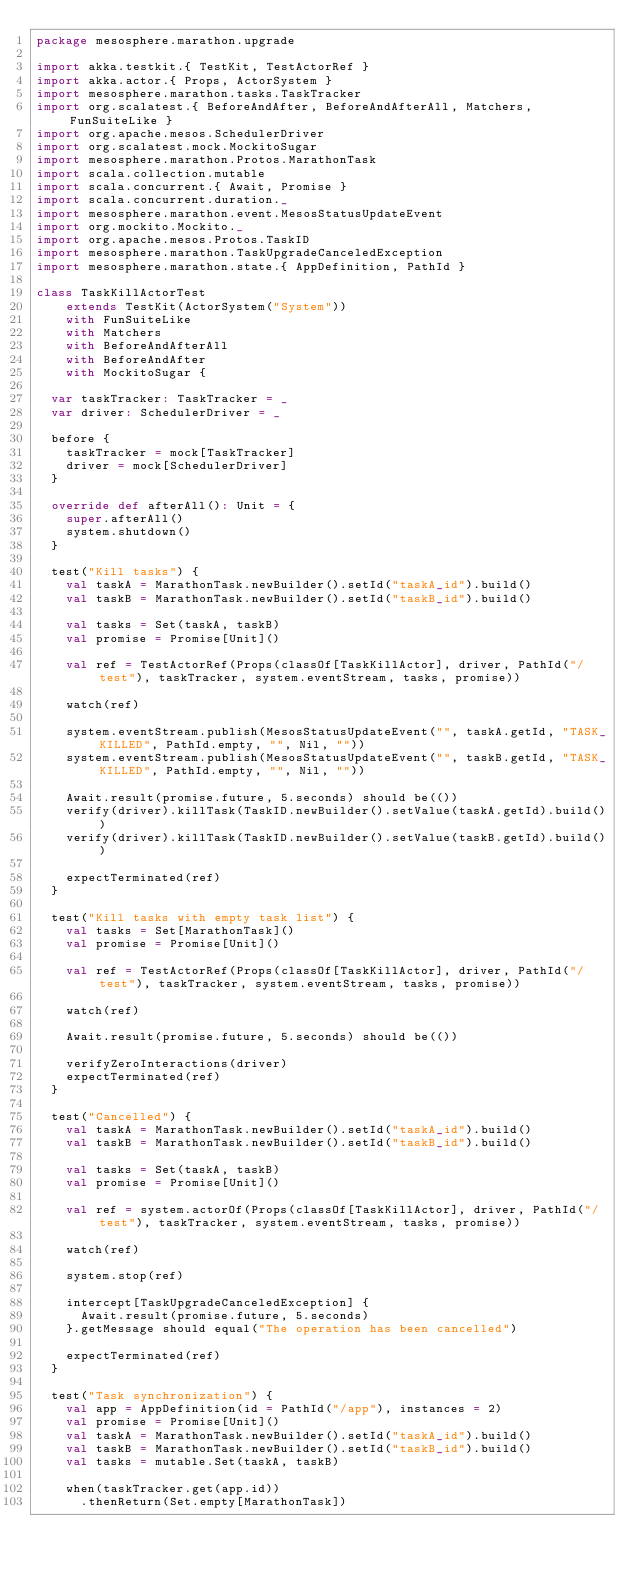<code> <loc_0><loc_0><loc_500><loc_500><_Scala_>package mesosphere.marathon.upgrade

import akka.testkit.{ TestKit, TestActorRef }
import akka.actor.{ Props, ActorSystem }
import mesosphere.marathon.tasks.TaskTracker
import org.scalatest.{ BeforeAndAfter, BeforeAndAfterAll, Matchers, FunSuiteLike }
import org.apache.mesos.SchedulerDriver
import org.scalatest.mock.MockitoSugar
import mesosphere.marathon.Protos.MarathonTask
import scala.collection.mutable
import scala.concurrent.{ Await, Promise }
import scala.concurrent.duration._
import mesosphere.marathon.event.MesosStatusUpdateEvent
import org.mockito.Mockito._
import org.apache.mesos.Protos.TaskID
import mesosphere.marathon.TaskUpgradeCanceledException
import mesosphere.marathon.state.{ AppDefinition, PathId }

class TaskKillActorTest
    extends TestKit(ActorSystem("System"))
    with FunSuiteLike
    with Matchers
    with BeforeAndAfterAll
    with BeforeAndAfter
    with MockitoSugar {

  var taskTracker: TaskTracker = _
  var driver: SchedulerDriver = _

  before {
    taskTracker = mock[TaskTracker]
    driver = mock[SchedulerDriver]
  }

  override def afterAll(): Unit = {
    super.afterAll()
    system.shutdown()
  }

  test("Kill tasks") {
    val taskA = MarathonTask.newBuilder().setId("taskA_id").build()
    val taskB = MarathonTask.newBuilder().setId("taskB_id").build()

    val tasks = Set(taskA, taskB)
    val promise = Promise[Unit]()

    val ref = TestActorRef(Props(classOf[TaskKillActor], driver, PathId("/test"), taskTracker, system.eventStream, tasks, promise))

    watch(ref)

    system.eventStream.publish(MesosStatusUpdateEvent("", taskA.getId, "TASK_KILLED", PathId.empty, "", Nil, ""))
    system.eventStream.publish(MesosStatusUpdateEvent("", taskB.getId, "TASK_KILLED", PathId.empty, "", Nil, ""))

    Await.result(promise.future, 5.seconds) should be(())
    verify(driver).killTask(TaskID.newBuilder().setValue(taskA.getId).build())
    verify(driver).killTask(TaskID.newBuilder().setValue(taskB.getId).build())

    expectTerminated(ref)
  }

  test("Kill tasks with empty task list") {
    val tasks = Set[MarathonTask]()
    val promise = Promise[Unit]()

    val ref = TestActorRef(Props(classOf[TaskKillActor], driver, PathId("/test"), taskTracker, system.eventStream, tasks, promise))

    watch(ref)

    Await.result(promise.future, 5.seconds) should be(())

    verifyZeroInteractions(driver)
    expectTerminated(ref)
  }

  test("Cancelled") {
    val taskA = MarathonTask.newBuilder().setId("taskA_id").build()
    val taskB = MarathonTask.newBuilder().setId("taskB_id").build()

    val tasks = Set(taskA, taskB)
    val promise = Promise[Unit]()

    val ref = system.actorOf(Props(classOf[TaskKillActor], driver, PathId("/test"), taskTracker, system.eventStream, tasks, promise))

    watch(ref)

    system.stop(ref)

    intercept[TaskUpgradeCanceledException] {
      Await.result(promise.future, 5.seconds)
    }.getMessage should equal("The operation has been cancelled")

    expectTerminated(ref)
  }

  test("Task synchronization") {
    val app = AppDefinition(id = PathId("/app"), instances = 2)
    val promise = Promise[Unit]()
    val taskA = MarathonTask.newBuilder().setId("taskA_id").build()
    val taskB = MarathonTask.newBuilder().setId("taskB_id").build()
    val tasks = mutable.Set(taskA, taskB)

    when(taskTracker.get(app.id))
      .thenReturn(Set.empty[MarathonTask])
</code> 